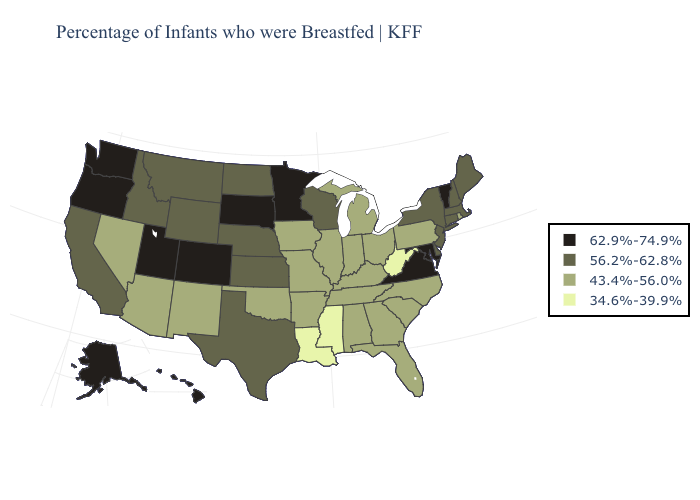Among the states that border Pennsylvania , which have the highest value?
Keep it brief. Maryland. Name the states that have a value in the range 56.2%-62.8%?
Write a very short answer. California, Connecticut, Delaware, Idaho, Kansas, Maine, Massachusetts, Montana, Nebraska, New Hampshire, New Jersey, New York, North Dakota, Texas, Wisconsin, Wyoming. Does Kentucky have the highest value in the South?
Short answer required. No. Does the map have missing data?
Quick response, please. No. Name the states that have a value in the range 62.9%-74.9%?
Concise answer only. Alaska, Colorado, Hawaii, Maryland, Minnesota, Oregon, South Dakota, Utah, Vermont, Virginia, Washington. What is the value of New Hampshire?
Keep it brief. 56.2%-62.8%. What is the highest value in the Northeast ?
Answer briefly. 62.9%-74.9%. What is the value of New Jersey?
Give a very brief answer. 56.2%-62.8%. What is the lowest value in the USA?
Be succinct. 34.6%-39.9%. Name the states that have a value in the range 62.9%-74.9%?
Be succinct. Alaska, Colorado, Hawaii, Maryland, Minnesota, Oregon, South Dakota, Utah, Vermont, Virginia, Washington. Does the first symbol in the legend represent the smallest category?
Short answer required. No. Name the states that have a value in the range 62.9%-74.9%?
Answer briefly. Alaska, Colorado, Hawaii, Maryland, Minnesota, Oregon, South Dakota, Utah, Vermont, Virginia, Washington. What is the value of Texas?
Answer briefly. 56.2%-62.8%. Is the legend a continuous bar?
Concise answer only. No. Does New Jersey have the highest value in the Northeast?
Short answer required. No. 